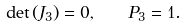<formula> <loc_0><loc_0><loc_500><loc_500>\det \left ( { J _ { 3 } } \right ) = 0 , \quad P _ { 3 } = 1 .</formula> 